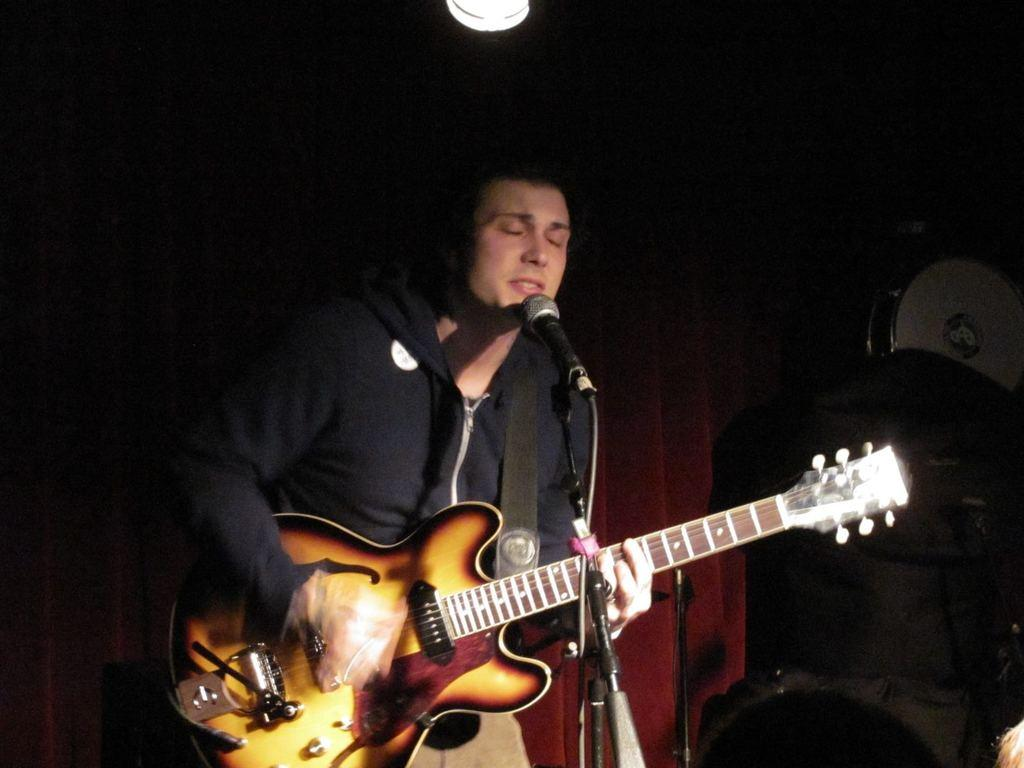What is the man in the image doing? The man is standing in front of a mic and holding a guitar. What instrument is the man holding? The man is holding a guitar. What can be seen in the background of the image? There is light visible in the background of the image, along with other unspecified elements. What type of cart is being used to transport the man's weight in the image? There is no cart present in the image, and the man's weight is not being transported. 